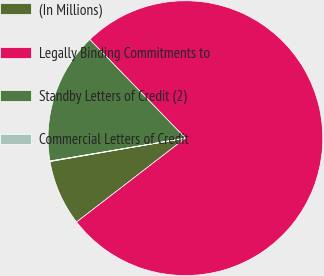Convert chart to OTSL. <chart><loc_0><loc_0><loc_500><loc_500><pie_chart><fcel>(In Millions)<fcel>Legally Binding Commitments to<fcel>Standby Letters of Credit (2)<fcel>Commercial Letters of Credit<nl><fcel>7.73%<fcel>76.81%<fcel>15.41%<fcel>0.06%<nl></chart> 